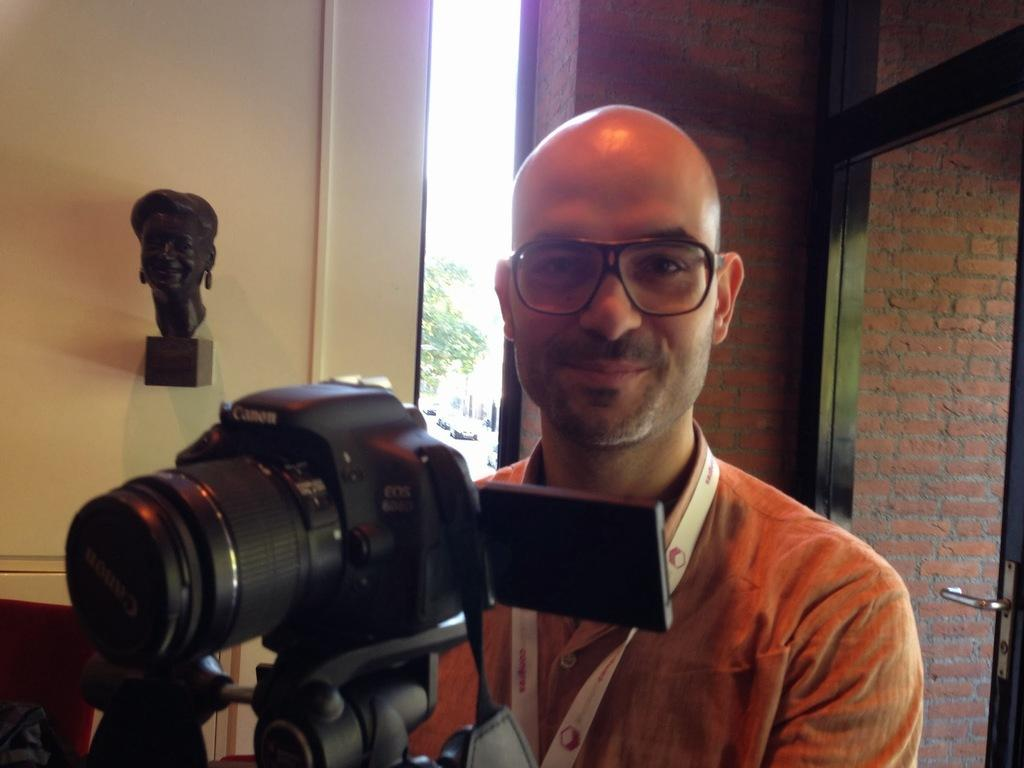What is the man in the image wearing on his face? The man in the image is wearing spectacles. What is the man interacting with in the image? There is a camera in front of the man. What can be seen on the wall in the image? There is a sculpture on the wall. What is visible in the distance in the image? Trees and vehicles are visible in the distance. What is the wall made of in the image? The wall is made of bricks. What feature is present on the door in the image? There is a door with a handle in the image. What type of milk is being used to support the sculpture on the wall? There is no milk present in the image, and the sculpture is not being supported by any substance. 